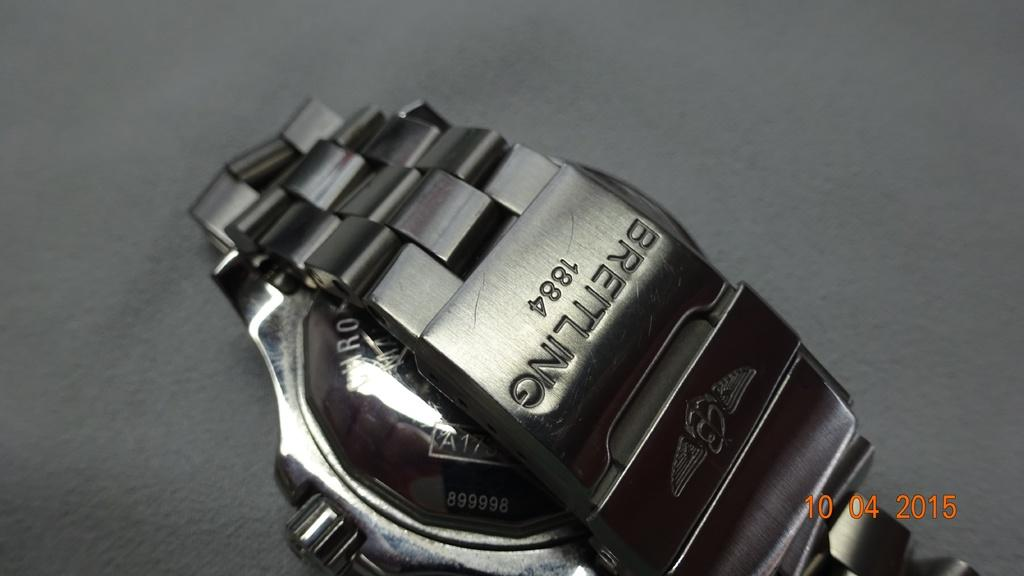<image>
Render a clear and concise summary of the photo. The backside of the band on a Bremling 1884 watch engraved in it. 